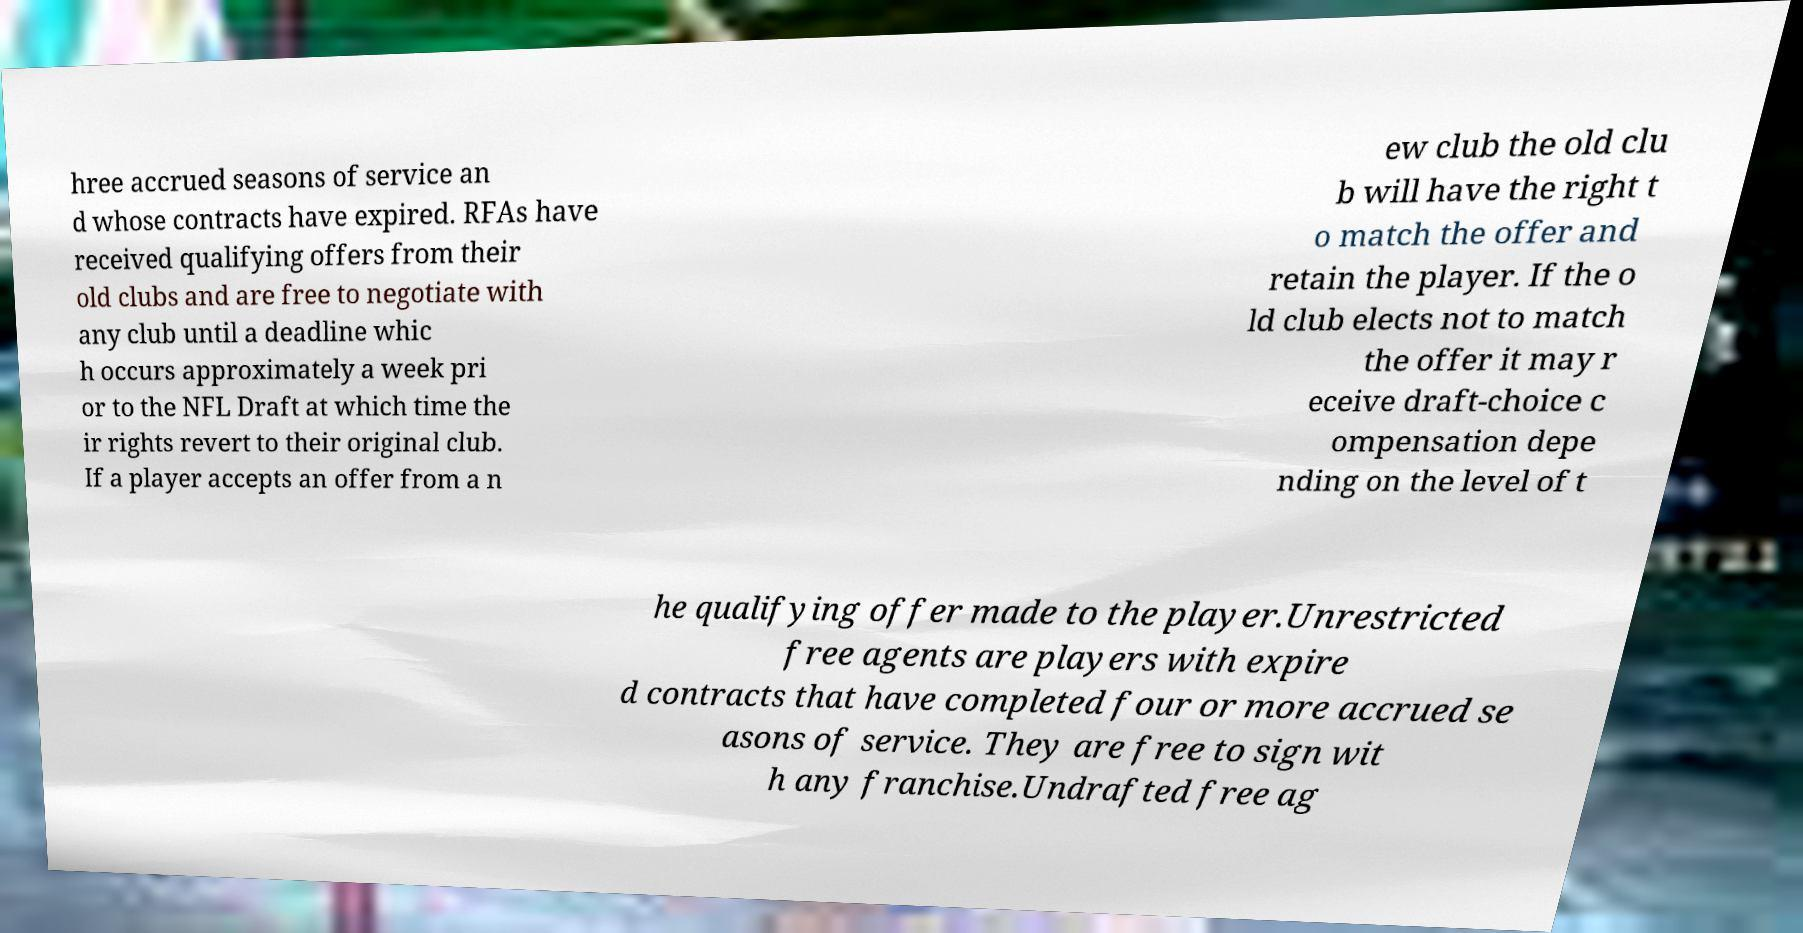There's text embedded in this image that I need extracted. Can you transcribe it verbatim? hree accrued seasons of service an d whose contracts have expired. RFAs have received qualifying offers from their old clubs and are free to negotiate with any club until a deadline whic h occurs approximately a week pri or to the NFL Draft at which time the ir rights revert to their original club. If a player accepts an offer from a n ew club the old clu b will have the right t o match the offer and retain the player. If the o ld club elects not to match the offer it may r eceive draft-choice c ompensation depe nding on the level of t he qualifying offer made to the player.Unrestricted free agents are players with expire d contracts that have completed four or more accrued se asons of service. They are free to sign wit h any franchise.Undrafted free ag 